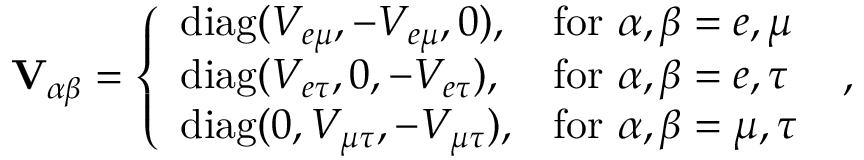Convert formula to latex. <formula><loc_0><loc_0><loc_500><loc_500>V _ { \alpha \beta } = \left \{ \begin{array} { l l } { d i a g ( V _ { e \mu } , - V _ { e \mu } , 0 ) , } & { f o r \alpha , \beta = e , \mu } \\ { d i a g ( V _ { e \tau } , 0 , - V _ { e \tau } ) , } & { f o r \alpha , \beta = e , \tau } \\ { d i a g ( 0 , V _ { \mu \tau } , - V _ { \mu \tau } ) , } & { f o r \alpha , \beta = \mu , \tau } \end{array} \, ,</formula> 